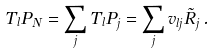Convert formula to latex. <formula><loc_0><loc_0><loc_500><loc_500>T _ { l } P _ { N } = \sum _ { j } T _ { l } P _ { j } = \sum _ { j } v _ { l j } \tilde { R } _ { j } \, .</formula> 